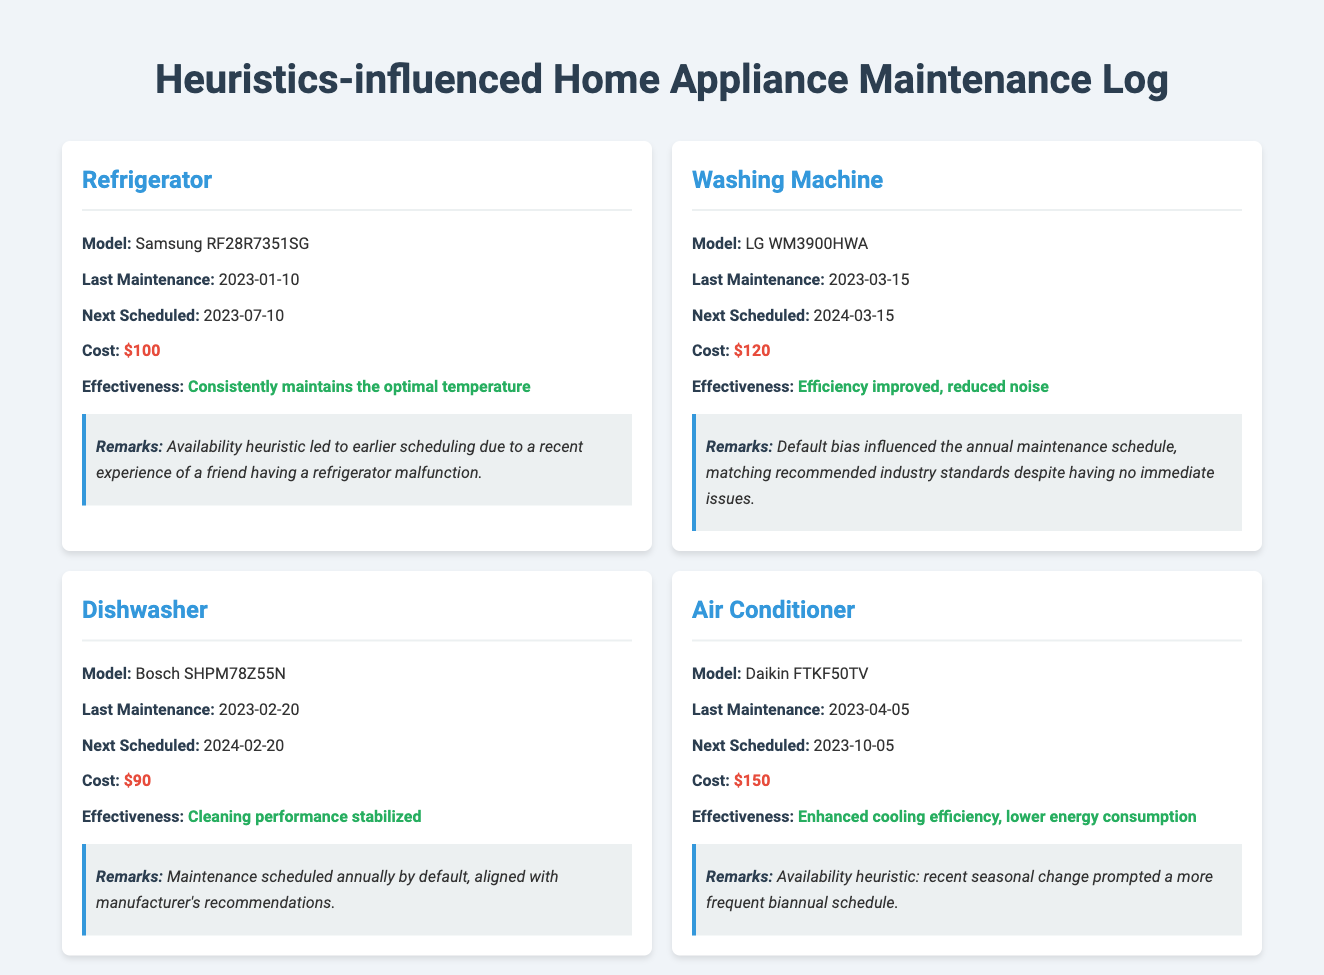what is the last maintenance date for the refrigerator? The last maintenance date for the refrigerator is mentioned in the log as 2023-01-10.
Answer: 2023-01-10 what is the cost of the washing machine maintenance? The cost associated with the maintenance of the washing machine is stated as $120.
Answer: $120 how often is the dishwasher scheduled for maintenance? The dishwasher is scheduled for maintenance annually, as indicated in the log.
Answer: Annually what was the effectiveness of the air conditioner's last maintenance? The air conditioner's effectiveness after the last maintenance is described as enhanced cooling efficiency and lower energy consumption.
Answer: Enhanced cooling efficiency, lower energy consumption which heuristic influenced the scheduling of the air conditioner? The availability heuristic was specifically mentioned as influencing the scheduling decisions for the air conditioner.
Answer: Availability heuristic what is the next scheduled maintenance for the dishwasher? The next scheduled maintenance for the dishwasher is documented as 2024-02-20.
Answer: 2024-02-20 what is the model of the refrigerator? The model of the refrigerator is stated as Samsung RF28R7351SG.
Answer: Samsung RF28R7351SG how did default bias affect the washing machine's maintenance schedule? The log indicates that default bias influenced the maintenance schedule to match industry standards despite no immediate issues.
Answer: Matched recommended industry standards what is the cleaning performance status of the dishwasher? The cleaning performance status of the dishwasher is noted as stabilized.
Answer: Stabilized 